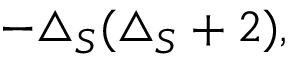Convert formula to latex. <formula><loc_0><loc_0><loc_500><loc_500>- \triangle _ { S } ( \triangle _ { S } + 2 ) ,</formula> 